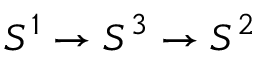<formula> <loc_0><loc_0><loc_500><loc_500>S ^ { 1 } \to S ^ { 3 } \to S ^ { 2 }</formula> 